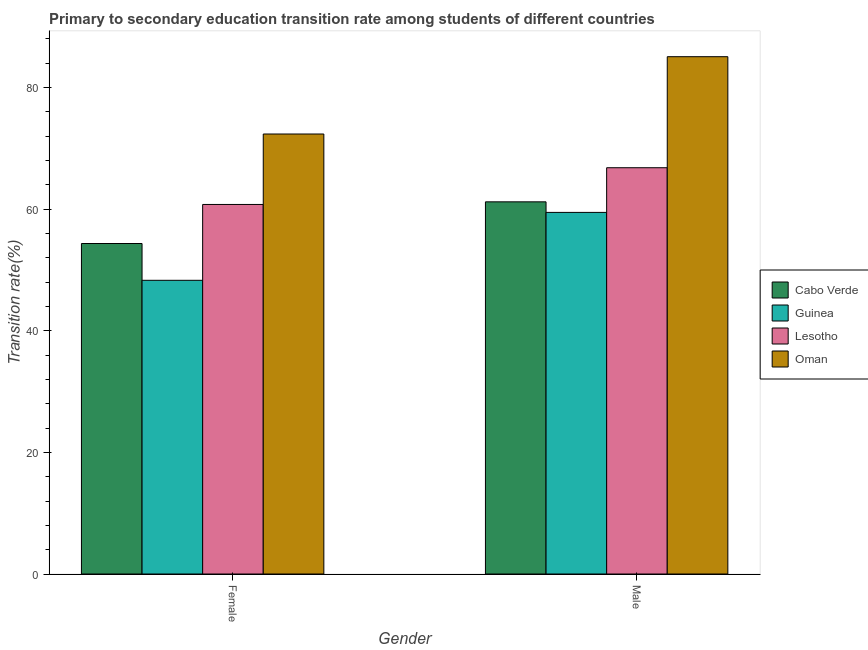Are the number of bars per tick equal to the number of legend labels?
Make the answer very short. Yes. What is the label of the 2nd group of bars from the left?
Offer a very short reply. Male. What is the transition rate among female students in Cabo Verde?
Provide a succinct answer. 54.35. Across all countries, what is the maximum transition rate among female students?
Offer a terse response. 72.36. Across all countries, what is the minimum transition rate among male students?
Make the answer very short. 59.47. In which country was the transition rate among male students maximum?
Keep it short and to the point. Oman. In which country was the transition rate among female students minimum?
Offer a terse response. Guinea. What is the total transition rate among male students in the graph?
Your response must be concise. 272.56. What is the difference between the transition rate among female students in Oman and that in Guinea?
Keep it short and to the point. 24.06. What is the difference between the transition rate among female students in Cabo Verde and the transition rate among male students in Oman?
Your answer should be compact. -30.72. What is the average transition rate among male students per country?
Make the answer very short. 68.14. What is the difference between the transition rate among female students and transition rate among male students in Guinea?
Your answer should be compact. -11.17. What is the ratio of the transition rate among female students in Lesotho to that in Oman?
Your answer should be compact. 0.84. Is the transition rate among male students in Lesotho less than that in Guinea?
Offer a very short reply. No. In how many countries, is the transition rate among female students greater than the average transition rate among female students taken over all countries?
Your answer should be compact. 2. What does the 3rd bar from the left in Male represents?
Keep it short and to the point. Lesotho. What does the 4th bar from the right in Male represents?
Ensure brevity in your answer.  Cabo Verde. How many bars are there?
Keep it short and to the point. 8. Are all the bars in the graph horizontal?
Offer a very short reply. No. Does the graph contain any zero values?
Offer a very short reply. No. Where does the legend appear in the graph?
Ensure brevity in your answer.  Center right. How many legend labels are there?
Give a very brief answer. 4. What is the title of the graph?
Offer a very short reply. Primary to secondary education transition rate among students of different countries. What is the label or title of the Y-axis?
Give a very brief answer. Transition rate(%). What is the Transition rate(%) in Cabo Verde in Female?
Offer a terse response. 54.35. What is the Transition rate(%) in Guinea in Female?
Offer a terse response. 48.3. What is the Transition rate(%) in Lesotho in Female?
Offer a terse response. 60.77. What is the Transition rate(%) in Oman in Female?
Give a very brief answer. 72.36. What is the Transition rate(%) in Cabo Verde in Male?
Your answer should be compact. 61.2. What is the Transition rate(%) in Guinea in Male?
Make the answer very short. 59.47. What is the Transition rate(%) in Lesotho in Male?
Provide a short and direct response. 66.81. What is the Transition rate(%) of Oman in Male?
Your answer should be compact. 85.07. Across all Gender, what is the maximum Transition rate(%) of Cabo Verde?
Provide a short and direct response. 61.2. Across all Gender, what is the maximum Transition rate(%) of Guinea?
Your answer should be compact. 59.47. Across all Gender, what is the maximum Transition rate(%) of Lesotho?
Keep it short and to the point. 66.81. Across all Gender, what is the maximum Transition rate(%) of Oman?
Provide a short and direct response. 85.07. Across all Gender, what is the minimum Transition rate(%) in Cabo Verde?
Your response must be concise. 54.35. Across all Gender, what is the minimum Transition rate(%) of Guinea?
Keep it short and to the point. 48.3. Across all Gender, what is the minimum Transition rate(%) of Lesotho?
Your answer should be very brief. 60.77. Across all Gender, what is the minimum Transition rate(%) in Oman?
Your answer should be compact. 72.36. What is the total Transition rate(%) of Cabo Verde in the graph?
Your answer should be compact. 115.56. What is the total Transition rate(%) in Guinea in the graph?
Your answer should be compact. 107.77. What is the total Transition rate(%) in Lesotho in the graph?
Offer a terse response. 127.59. What is the total Transition rate(%) in Oman in the graph?
Offer a terse response. 157.44. What is the difference between the Transition rate(%) of Cabo Verde in Female and that in Male?
Your response must be concise. -6.85. What is the difference between the Transition rate(%) in Guinea in Female and that in Male?
Offer a terse response. -11.17. What is the difference between the Transition rate(%) of Lesotho in Female and that in Male?
Your response must be concise. -6.04. What is the difference between the Transition rate(%) in Oman in Female and that in Male?
Keep it short and to the point. -12.71. What is the difference between the Transition rate(%) in Cabo Verde in Female and the Transition rate(%) in Guinea in Male?
Keep it short and to the point. -5.12. What is the difference between the Transition rate(%) of Cabo Verde in Female and the Transition rate(%) of Lesotho in Male?
Your answer should be very brief. -12.46. What is the difference between the Transition rate(%) in Cabo Verde in Female and the Transition rate(%) in Oman in Male?
Make the answer very short. -30.72. What is the difference between the Transition rate(%) in Guinea in Female and the Transition rate(%) in Lesotho in Male?
Provide a short and direct response. -18.51. What is the difference between the Transition rate(%) of Guinea in Female and the Transition rate(%) of Oman in Male?
Ensure brevity in your answer.  -36.77. What is the difference between the Transition rate(%) in Lesotho in Female and the Transition rate(%) in Oman in Male?
Give a very brief answer. -24.3. What is the average Transition rate(%) of Cabo Verde per Gender?
Keep it short and to the point. 57.78. What is the average Transition rate(%) of Guinea per Gender?
Your answer should be compact. 53.88. What is the average Transition rate(%) of Lesotho per Gender?
Give a very brief answer. 63.79. What is the average Transition rate(%) in Oman per Gender?
Give a very brief answer. 78.72. What is the difference between the Transition rate(%) of Cabo Verde and Transition rate(%) of Guinea in Female?
Your answer should be very brief. 6.05. What is the difference between the Transition rate(%) in Cabo Verde and Transition rate(%) in Lesotho in Female?
Make the answer very short. -6.42. What is the difference between the Transition rate(%) in Cabo Verde and Transition rate(%) in Oman in Female?
Provide a succinct answer. -18.01. What is the difference between the Transition rate(%) of Guinea and Transition rate(%) of Lesotho in Female?
Offer a terse response. -12.47. What is the difference between the Transition rate(%) in Guinea and Transition rate(%) in Oman in Female?
Give a very brief answer. -24.06. What is the difference between the Transition rate(%) in Lesotho and Transition rate(%) in Oman in Female?
Your response must be concise. -11.59. What is the difference between the Transition rate(%) of Cabo Verde and Transition rate(%) of Guinea in Male?
Offer a terse response. 1.74. What is the difference between the Transition rate(%) of Cabo Verde and Transition rate(%) of Lesotho in Male?
Provide a succinct answer. -5.61. What is the difference between the Transition rate(%) in Cabo Verde and Transition rate(%) in Oman in Male?
Provide a short and direct response. -23.87. What is the difference between the Transition rate(%) of Guinea and Transition rate(%) of Lesotho in Male?
Your response must be concise. -7.35. What is the difference between the Transition rate(%) of Guinea and Transition rate(%) of Oman in Male?
Your response must be concise. -25.61. What is the difference between the Transition rate(%) in Lesotho and Transition rate(%) in Oman in Male?
Your answer should be compact. -18.26. What is the ratio of the Transition rate(%) of Cabo Verde in Female to that in Male?
Offer a terse response. 0.89. What is the ratio of the Transition rate(%) in Guinea in Female to that in Male?
Give a very brief answer. 0.81. What is the ratio of the Transition rate(%) in Lesotho in Female to that in Male?
Offer a very short reply. 0.91. What is the ratio of the Transition rate(%) in Oman in Female to that in Male?
Your answer should be compact. 0.85. What is the difference between the highest and the second highest Transition rate(%) of Cabo Verde?
Your answer should be compact. 6.85. What is the difference between the highest and the second highest Transition rate(%) in Guinea?
Offer a very short reply. 11.17. What is the difference between the highest and the second highest Transition rate(%) in Lesotho?
Give a very brief answer. 6.04. What is the difference between the highest and the second highest Transition rate(%) of Oman?
Ensure brevity in your answer.  12.71. What is the difference between the highest and the lowest Transition rate(%) in Cabo Verde?
Keep it short and to the point. 6.85. What is the difference between the highest and the lowest Transition rate(%) in Guinea?
Offer a very short reply. 11.17. What is the difference between the highest and the lowest Transition rate(%) in Lesotho?
Your response must be concise. 6.04. What is the difference between the highest and the lowest Transition rate(%) in Oman?
Provide a short and direct response. 12.71. 